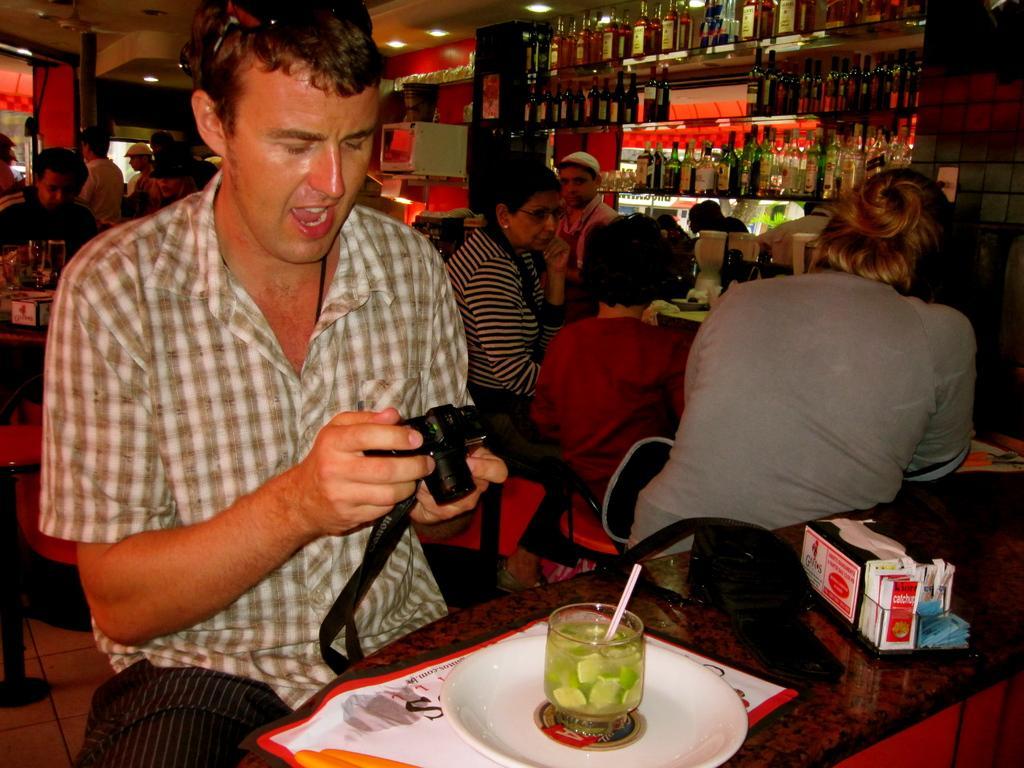Please provide a concise description of this image. There is a group of people. There is a table. There is a plate,banner,spoon on a table. We can see in the background there is a wine shop. 